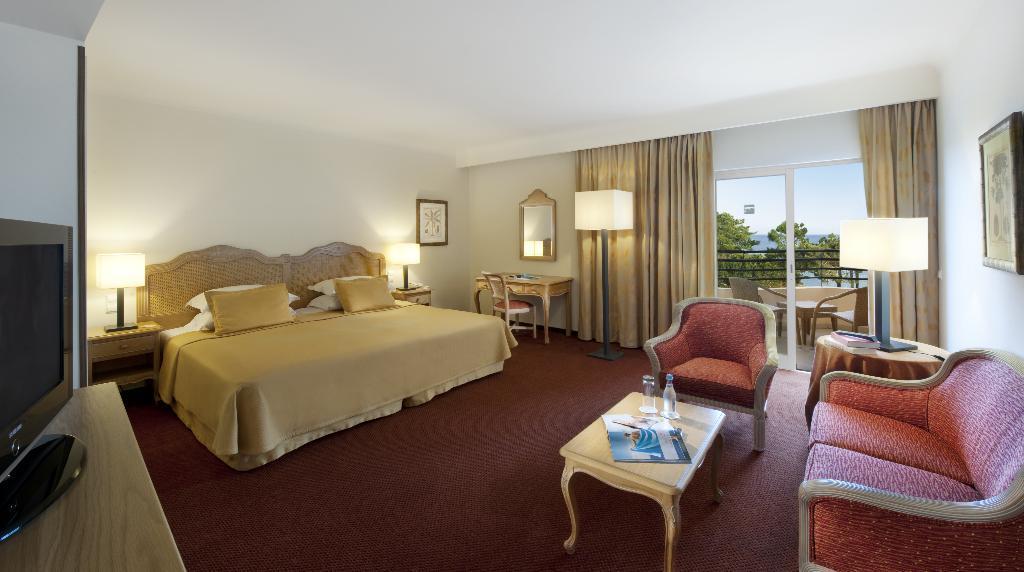In one or two sentences, can you explain what this image depicts? In this picture we can see a room with bed pillows on it, television, chair, sofa, table and on table we can see book, glass, bottle and lamp here we can see curtains to the window and from window we can see trees, sky. 